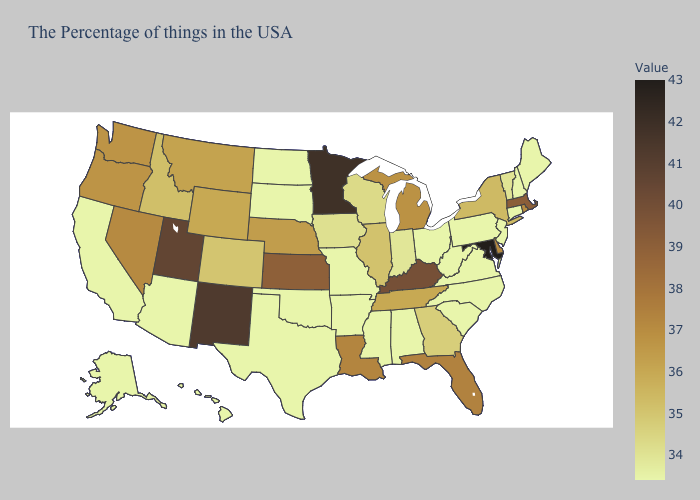Does North Carolina have the lowest value in the USA?
Be succinct. Yes. Does Georgia have the highest value in the South?
Write a very short answer. No. Does Nevada have a lower value than South Dakota?
Quick response, please. No. Which states have the highest value in the USA?
Keep it brief. Maryland. Which states have the lowest value in the USA?
Write a very short answer. Maine, New Hampshire, Connecticut, New Jersey, Pennsylvania, Virginia, North Carolina, South Carolina, West Virginia, Ohio, Alabama, Mississippi, Missouri, Arkansas, Oklahoma, Texas, South Dakota, North Dakota, Arizona, California, Alaska, Hawaii. Does Iowa have the highest value in the MidWest?
Keep it brief. No. Which states hav the highest value in the MidWest?
Write a very short answer. Minnesota. Which states have the lowest value in the MidWest?
Write a very short answer. Ohio, Missouri, South Dakota, North Dakota. Does the map have missing data?
Give a very brief answer. No. Which states have the lowest value in the USA?
Write a very short answer. Maine, New Hampshire, Connecticut, New Jersey, Pennsylvania, Virginia, North Carolina, South Carolina, West Virginia, Ohio, Alabama, Mississippi, Missouri, Arkansas, Oklahoma, Texas, South Dakota, North Dakota, Arizona, California, Alaska, Hawaii. 